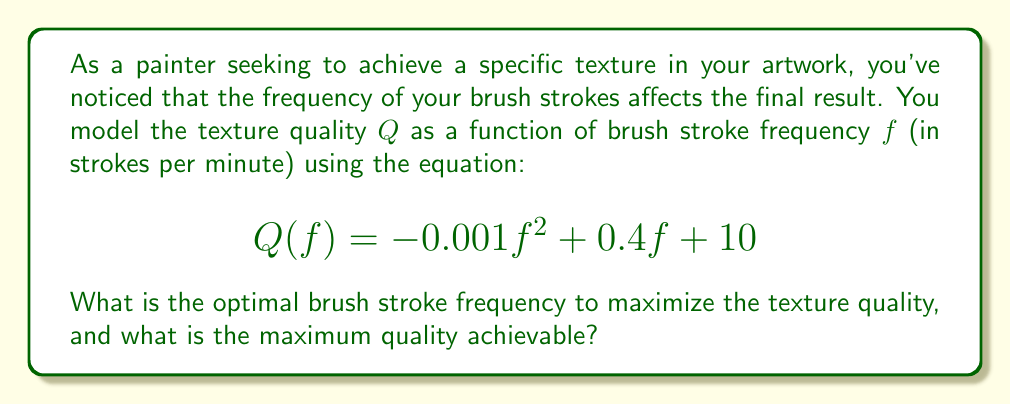Provide a solution to this math problem. To solve this problem, we need to follow these steps:

1) The texture quality function $Q(f)$ is a quadratic function of the form $ax^2 + bx + c$, where:
   $a = -0.001$
   $b = 0.4$
   $c = 10$

2) To find the maximum of a quadratic function, we need to find the vertex of the parabola. The x-coordinate of the vertex gives us the optimal frequency, and the y-coordinate gives us the maximum quality.

3) For a quadratic function $ax^2 + bx + c$, the x-coordinate of the vertex is given by $-\frac{b}{2a}$. So, the optimal frequency $f_{opt}$ is:

   $$f_{opt} = -\frac{b}{2a} = -\frac{0.4}{2(-0.001)} = 200$$

4) To find the maximum quality, we substitute this optimal frequency back into our original equation:

   $$Q_{max} = Q(200) = -0.001(200)^2 + 0.4(200) + 10$$
   $$= -40 + 80 + 10 = 50$$

5) Therefore, the optimal brush stroke frequency is 200 strokes per minute, and the maximum achievable quality is 50.
Answer: The optimal brush stroke frequency is 200 strokes per minute, and the maximum achievable quality is 50. 